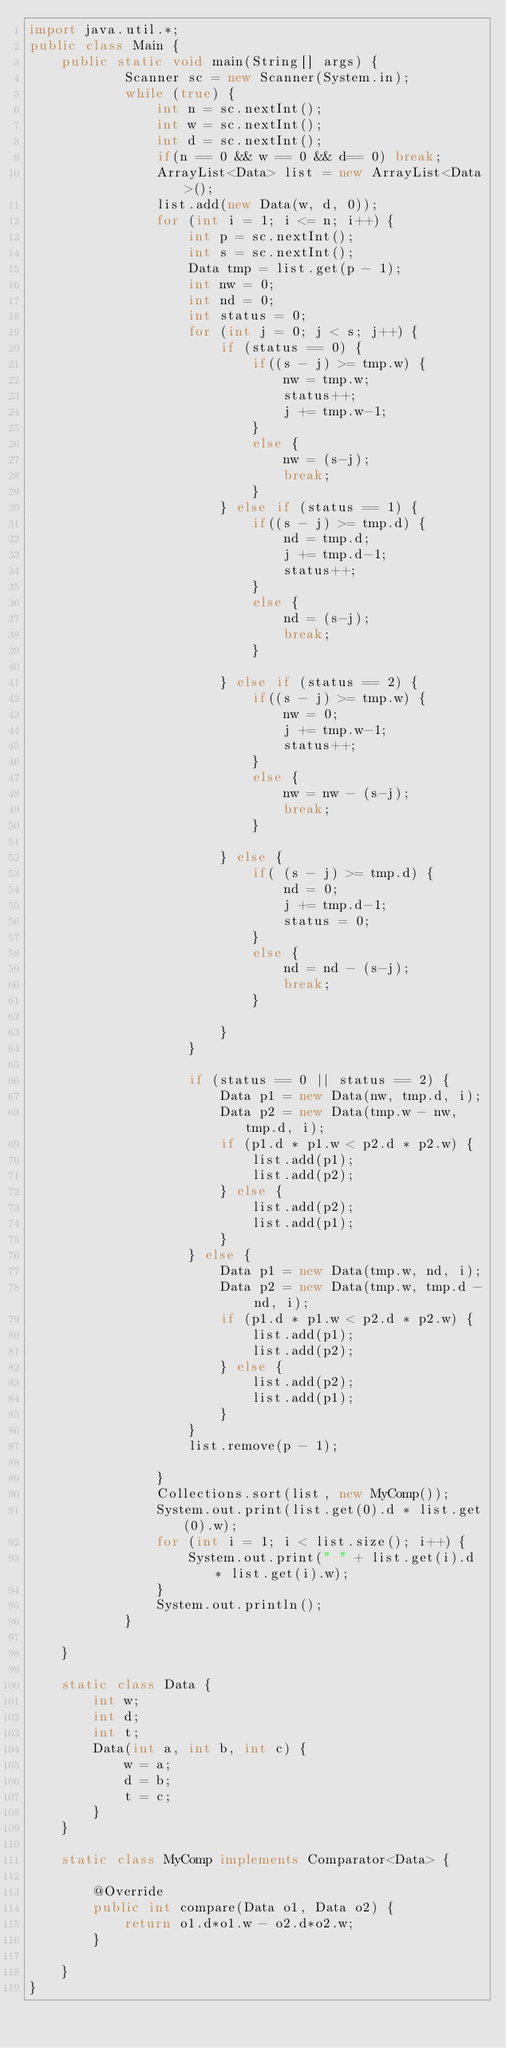<code> <loc_0><loc_0><loc_500><loc_500><_Java_>import java.util.*;
public class Main {
	public static void main(String[] args) {
			Scanner sc = new Scanner(System.in);
			while (true) {
				int n = sc.nextInt();
				int w = sc.nextInt();
				int d = sc.nextInt();
				if(n == 0 && w == 0 && d== 0) break;
				ArrayList<Data> list = new ArrayList<Data>();
				list.add(new Data(w, d, 0));
				for (int i = 1; i <= n; i++) {
					int p = sc.nextInt();
					int s = sc.nextInt();
					Data tmp = list.get(p - 1);
					int nw = 0;
					int nd = 0;
					int status = 0;
					for (int j = 0; j < s; j++) {
						if (status == 0) {
							if((s - j) >= tmp.w) {
								nw = tmp.w;
								status++;
								j += tmp.w-1;
							}
							else {
								nw = (s-j);
								break;
							}
						} else if (status == 1) {
							if((s - j) >= tmp.d) {
								nd = tmp.d;
								j += tmp.d-1;
								status++;
							}
							else {
								nd = (s-j);
								break;
							}
							
						} else if (status == 2) {
							if((s - j) >= tmp.w) {
								nw = 0;
								j += tmp.w-1;
								status++;
							}
							else {
								nw = nw - (s-j);
								break;
							}

						} else {
							if( (s - j) >= tmp.d) {
								nd = 0;
								j += tmp.d-1;
								status = 0;
							}
							else {
								nd = nd - (s-j);
								break;
							}

						}
					}

					if (status == 0 || status == 2) {
						Data p1 = new Data(nw, tmp.d, i);
						Data p2 = new Data(tmp.w - nw, tmp.d, i);
						if (p1.d * p1.w < p2.d * p2.w) {
							list.add(p1);
							list.add(p2);
						} else {
							list.add(p2);
							list.add(p1);
						}
					} else {
						Data p1 = new Data(tmp.w, nd, i);
						Data p2 = new Data(tmp.w, tmp.d - nd, i);
						if (p1.d * p1.w < p2.d * p2.w) {
							list.add(p1);
							list.add(p2);
						} else {
							list.add(p2);
							list.add(p1);
						}
					}
					list.remove(p - 1);

				}
				Collections.sort(list, new MyComp());
				System.out.print(list.get(0).d * list.get(0).w);
				for (int i = 1; i < list.size(); i++) {
					System.out.print(" " + list.get(i).d * list.get(i).w);
				}
				System.out.println();
			}
			
	}
	
	static class Data {
		int w;
		int d;
		int t;
		Data(int a, int b, int c) {
			w = a;
			d = b;
			t = c;
		}
	}
	
	static class MyComp implements Comparator<Data> {

		@Override
		public int compare(Data o1, Data o2) {
			return o1.d*o1.w - o2.d*o2.w;
		}
		
	}
}</code> 